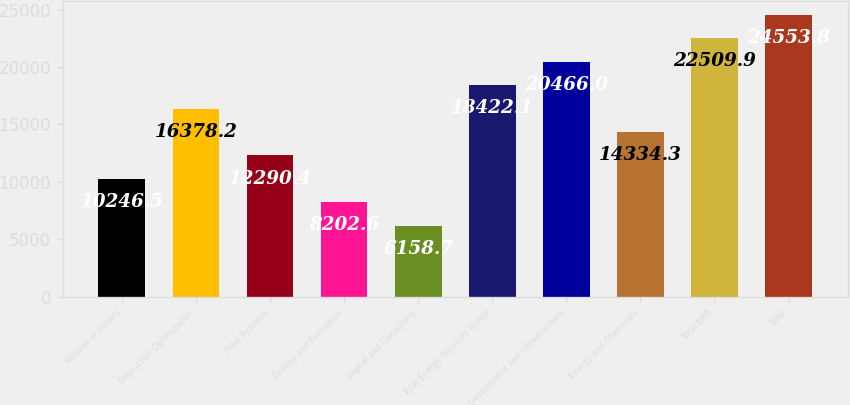<chart> <loc_0><loc_0><loc_500><loc_500><bar_chart><fcel>Millions of dollars<fcel>Production Optimization<fcel>Fluid Systems<fcel>Drilling and Formation<fcel>Digital and Consulting<fcel>Total Energy Services Group<fcel>Government and Infrastructure<fcel>Energy and Chemicals<fcel>Total KBR<fcel>Total<nl><fcel>10246.5<fcel>16378.2<fcel>12290.4<fcel>8202.6<fcel>6158.7<fcel>18422.1<fcel>20466<fcel>14334.3<fcel>22509.9<fcel>24553.8<nl></chart> 